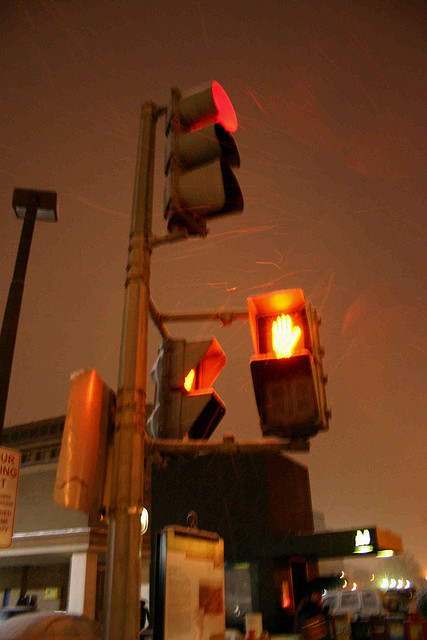What is the shape that says not to walk? The shape indicating not to walk is a hand, shown prominently in an illuminated traffic signal intended for pedestrians. 